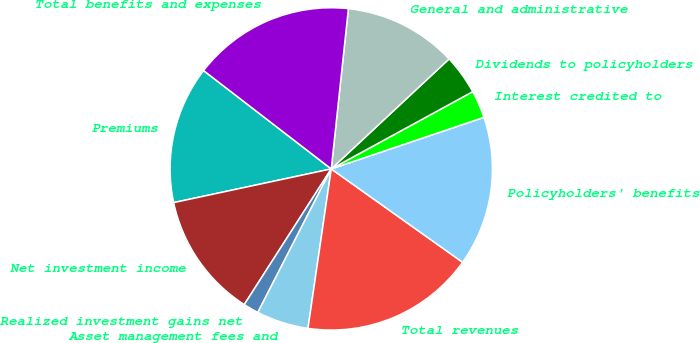<chart> <loc_0><loc_0><loc_500><loc_500><pie_chart><fcel>Premiums<fcel>Net investment income<fcel>Realized investment gains net<fcel>Asset management fees and<fcel>Total revenues<fcel>Policyholders' benefits<fcel>Interest credited to<fcel>Dividends to policyholders<fcel>General and administrative<fcel>Total benefits and expenses<nl><fcel>13.8%<fcel>12.57%<fcel>1.55%<fcel>5.22%<fcel>17.47%<fcel>15.02%<fcel>2.77%<fcel>4.0%<fcel>11.35%<fcel>16.25%<nl></chart> 